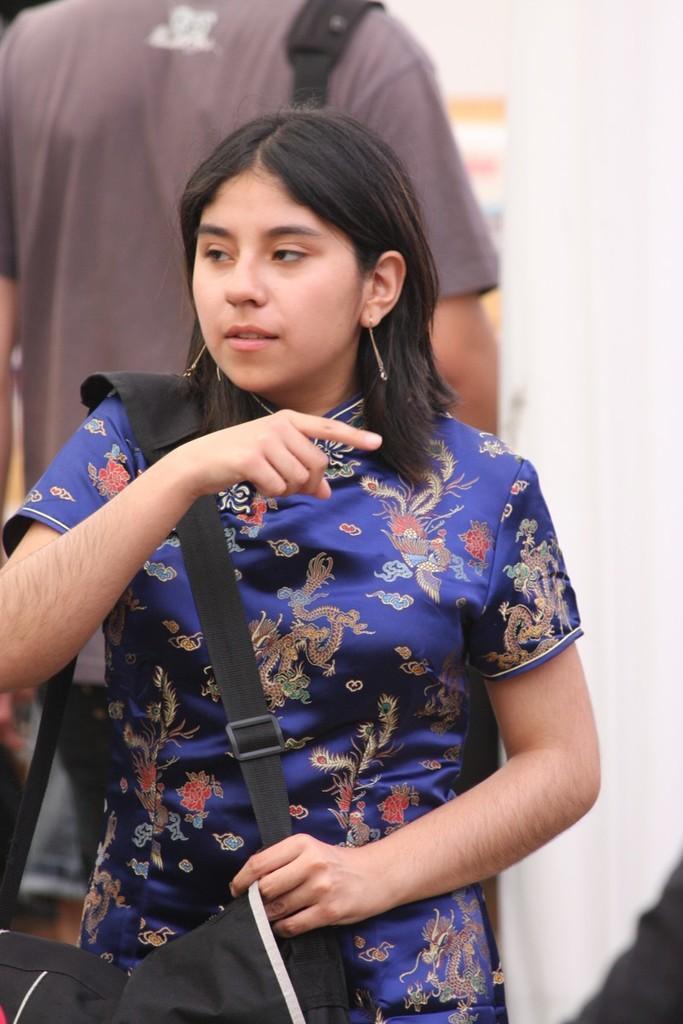Please provide a concise description of this image. In the foreground of this picture we can see a woman wearing blue color dress, black color sling bag and seems to be standing. In the background we can see a person seems to be wearing t-shirt and we can see a white color object seems to be the curtain and we can see some other objects. 